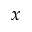Convert formula to latex. <formula><loc_0><loc_0><loc_500><loc_500>x</formula> 